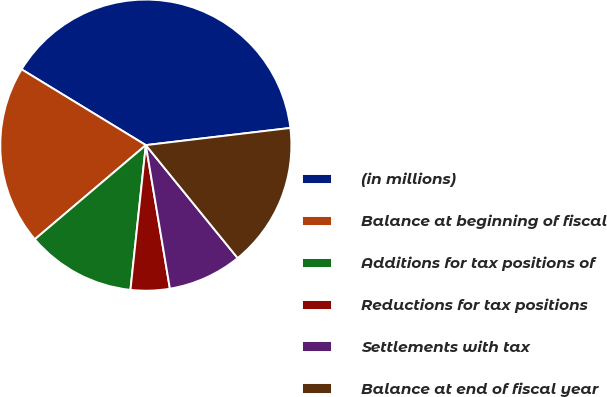Convert chart. <chart><loc_0><loc_0><loc_500><loc_500><pie_chart><fcel>(in millions)<fcel>Balance at beginning of fiscal<fcel>Additions for tax positions of<fcel>Reductions for tax positions<fcel>Settlements with tax<fcel>Balance at end of fiscal year<nl><fcel>39.4%<fcel>19.91%<fcel>12.12%<fcel>4.33%<fcel>8.22%<fcel>16.02%<nl></chart> 